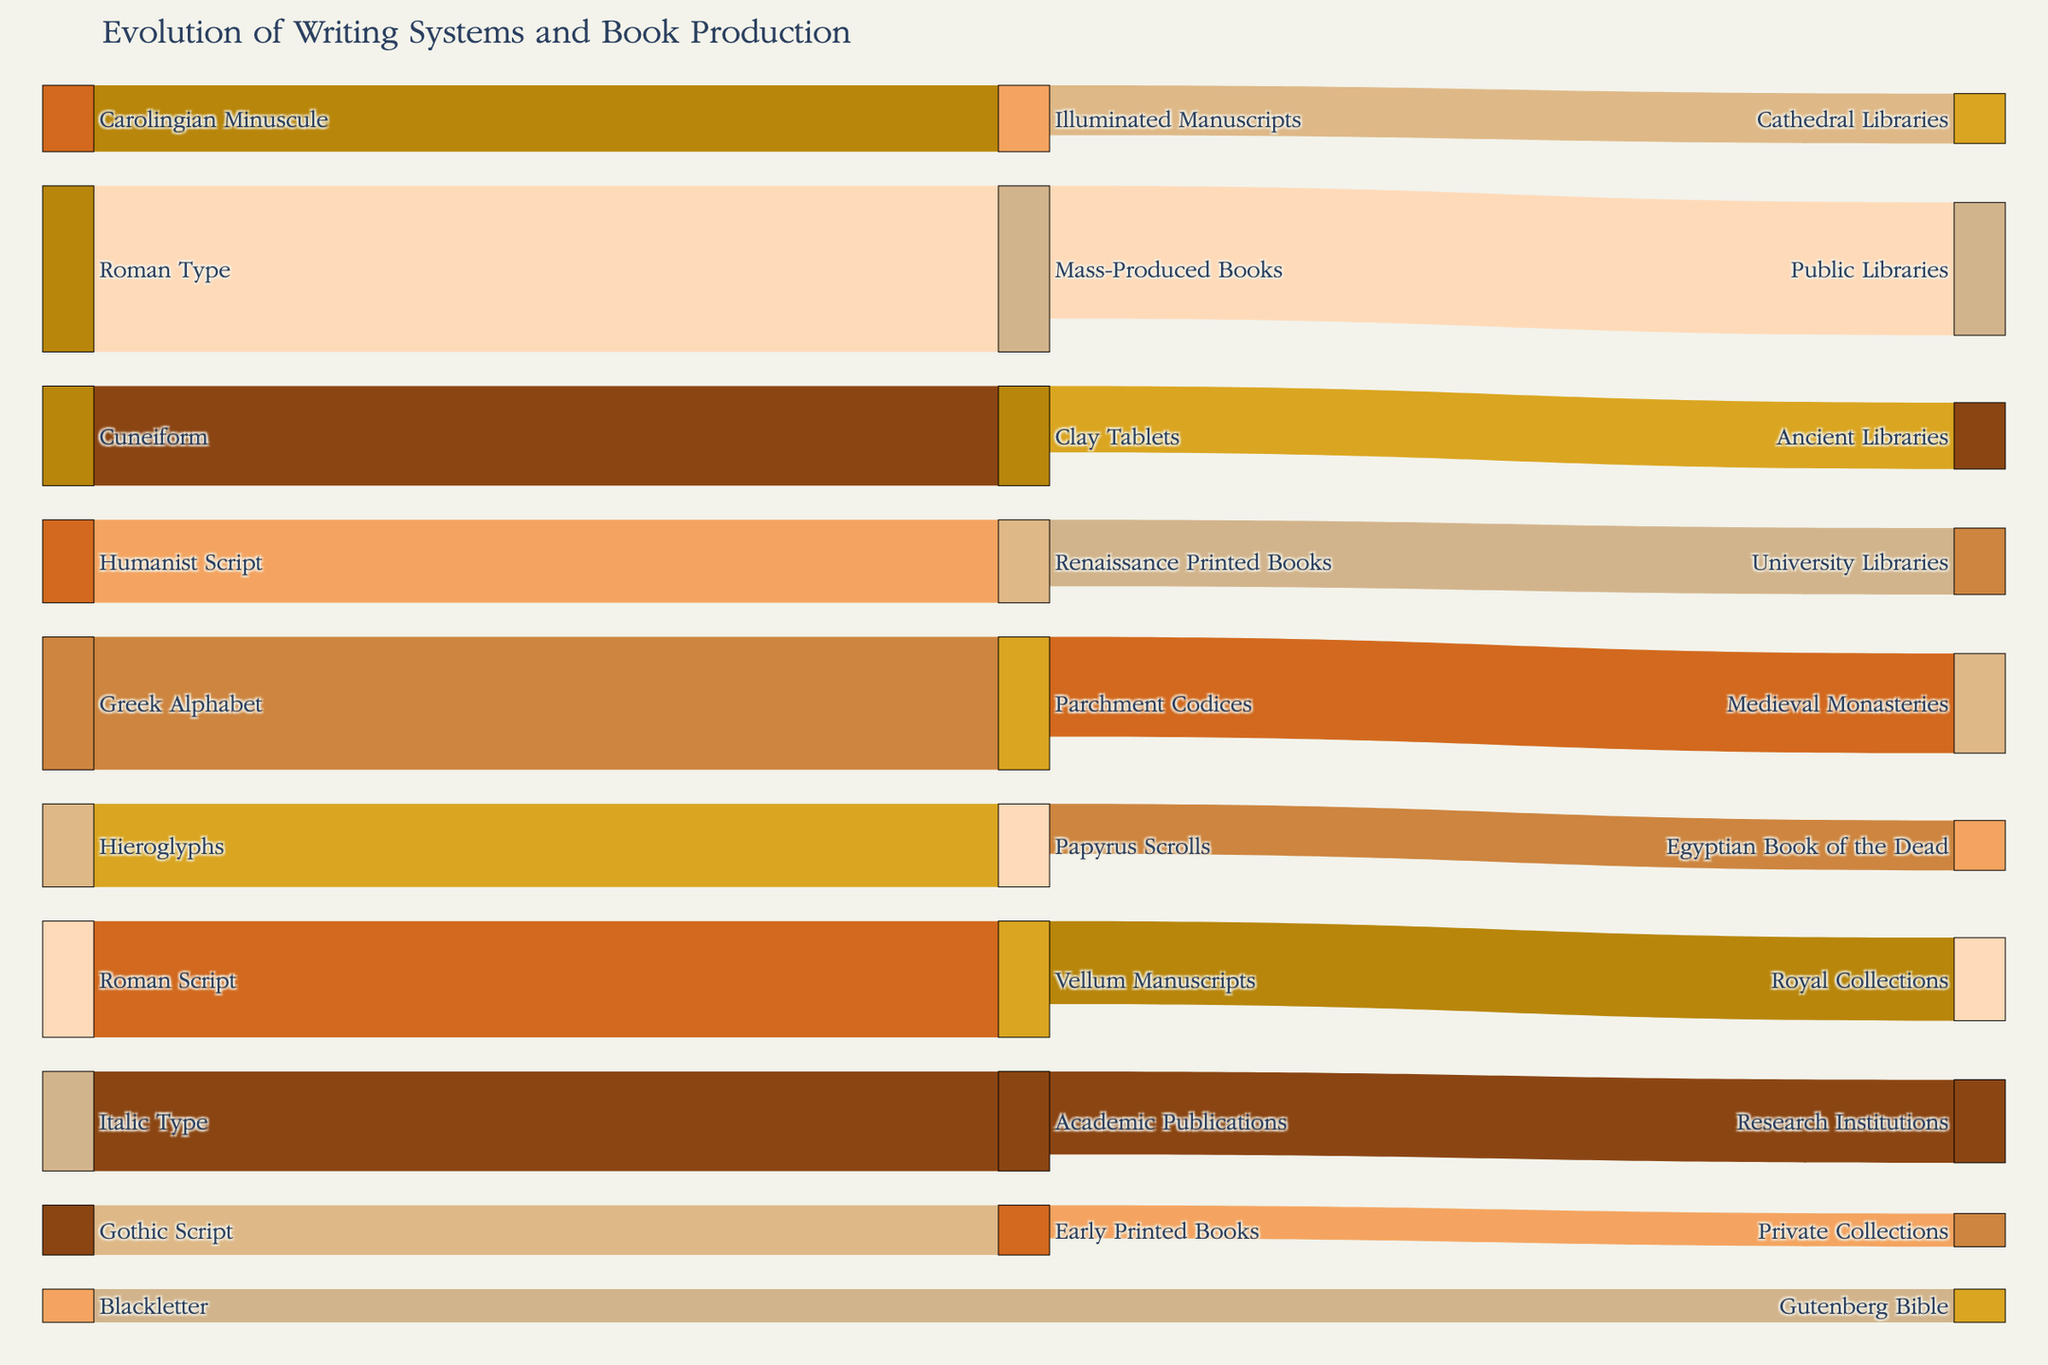Which writing system has the most significant influence on book production, according to the diagram? The Roman Type has the most significant influence, as it has a flow value of 50, which is higher than any other source in the diagram.
Answer: Roman Type What is the total value of book production types influenced by alphabetic writing systems (Greek Alphabet, Roman Script, Carolingian Minuscule, Gothic Script, Humanist Script, Blackletter)? Add the values of Parchment Codices (40), Vellum Manuscripts (35), Illuminated Manuscripts (20), Early Printed Books (15), Renaissance Printed Books (25), and Gutenberg Bible (10): 40 + 35 + 20 + 15 + 25 + 10 = 145
Answer: 145 What is the flow value between the Greek Alphabet and its corresponding book production type? The flow value between the Greek Alphabet and Parchment Codices is 40, as indicated in the diagram.
Answer: 40 Which book production type does the Roman Script influence, and what is its significance value? The Roman Script influences Vellum Manuscripts with a significance value of 35, as highlighted in the diagram.
Answer: Vellum Manuscripts, 35 Compare the importance of the Carolingian Minuscule and Gothic Script in terms of their influence on book production. Which has a higher value? The Carolingian Minuscule has a value of 20 (Illuminated Manuscripts), while the Gothic Script has 15 (Early Printed Books). The Carolingian Minuscule has a higher value.
Answer: Carolingian Minuscule How much influence does the most impactful modern writing system (Italic Type) have on academic publications? The Italic Type influences Academic Publications with a value of 30, as seen in the diagram.
Answer: 30 What is the total value of book production types dedicated to libraries (Ancient Libraries, Egyptian Book of the Dead, Medieval Monasteries, Cathedral Libraries, University Libraries, Public Libraries)? Sum the values of Ancient Libraries (20), Egyptian Book of the Dead (15), Medieval Monasteries (30), Cathedral Libraries (15), University Libraries (20), and Public Libraries (40): 20 + 15 + 30 + 15 + 20 + 40 = 140
Answer: 140 Which writing system influences both Parchment Codices and Vellum Manuscripts? Only the Greek Alphabet and the Roman Script influence Parchment Codices and Vellum Manuscripts, respectively; no single writing system influences both.
Answer: None Out of the major categories of book production types, which category has the least influence? Private Collections influenced by Early Printed Books has the least value of 10 among all categories in the diagram.
Answer: Private Collections What is the cumulative impact of writing systems on Renaissance Printed Books and Academic Publications? Add the values for Renaissance Printed Books (25) and Academic Publications (30): 25 + 30 = 55
Answer: 55 